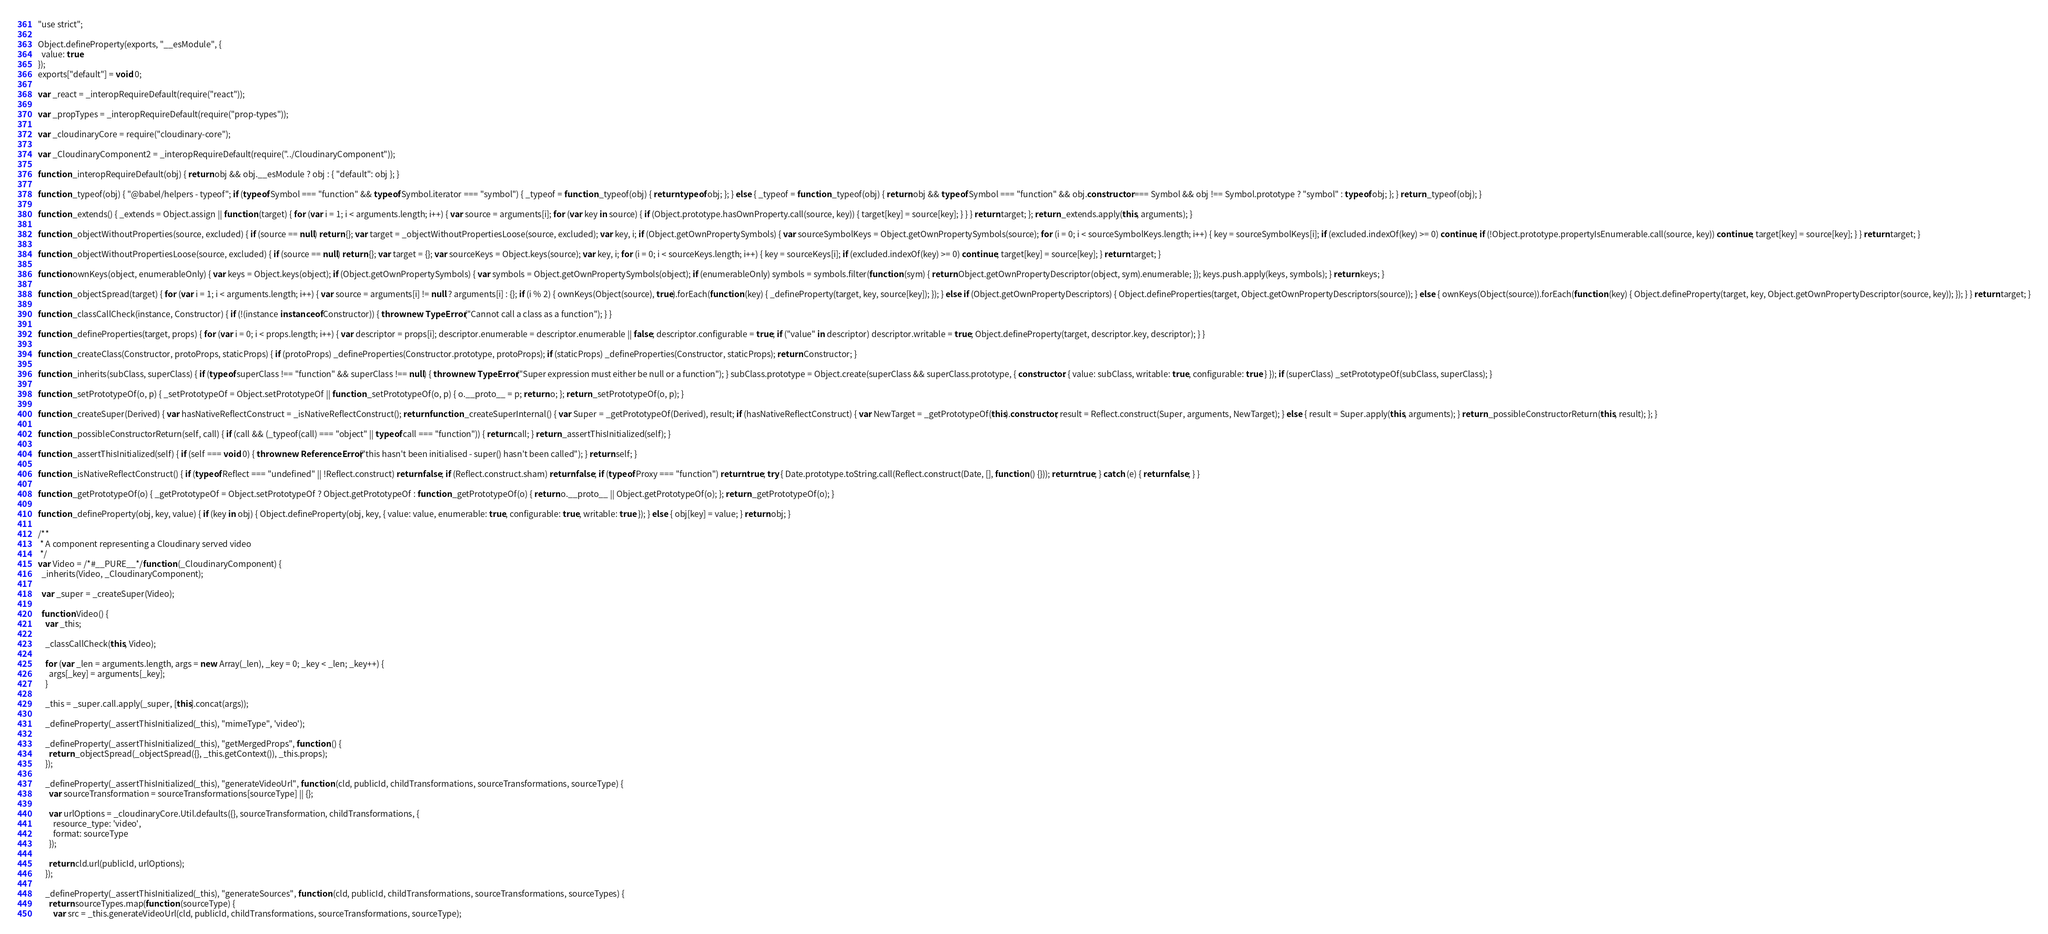Convert code to text. <code><loc_0><loc_0><loc_500><loc_500><_JavaScript_>"use strict";

Object.defineProperty(exports, "__esModule", {
  value: true
});
exports["default"] = void 0;

var _react = _interopRequireDefault(require("react"));

var _propTypes = _interopRequireDefault(require("prop-types"));

var _cloudinaryCore = require("cloudinary-core");

var _CloudinaryComponent2 = _interopRequireDefault(require("../CloudinaryComponent"));

function _interopRequireDefault(obj) { return obj && obj.__esModule ? obj : { "default": obj }; }

function _typeof(obj) { "@babel/helpers - typeof"; if (typeof Symbol === "function" && typeof Symbol.iterator === "symbol") { _typeof = function _typeof(obj) { return typeof obj; }; } else { _typeof = function _typeof(obj) { return obj && typeof Symbol === "function" && obj.constructor === Symbol && obj !== Symbol.prototype ? "symbol" : typeof obj; }; } return _typeof(obj); }

function _extends() { _extends = Object.assign || function (target) { for (var i = 1; i < arguments.length; i++) { var source = arguments[i]; for (var key in source) { if (Object.prototype.hasOwnProperty.call(source, key)) { target[key] = source[key]; } } } return target; }; return _extends.apply(this, arguments); }

function _objectWithoutProperties(source, excluded) { if (source == null) return {}; var target = _objectWithoutPropertiesLoose(source, excluded); var key, i; if (Object.getOwnPropertySymbols) { var sourceSymbolKeys = Object.getOwnPropertySymbols(source); for (i = 0; i < sourceSymbolKeys.length; i++) { key = sourceSymbolKeys[i]; if (excluded.indexOf(key) >= 0) continue; if (!Object.prototype.propertyIsEnumerable.call(source, key)) continue; target[key] = source[key]; } } return target; }

function _objectWithoutPropertiesLoose(source, excluded) { if (source == null) return {}; var target = {}; var sourceKeys = Object.keys(source); var key, i; for (i = 0; i < sourceKeys.length; i++) { key = sourceKeys[i]; if (excluded.indexOf(key) >= 0) continue; target[key] = source[key]; } return target; }

function ownKeys(object, enumerableOnly) { var keys = Object.keys(object); if (Object.getOwnPropertySymbols) { var symbols = Object.getOwnPropertySymbols(object); if (enumerableOnly) symbols = symbols.filter(function (sym) { return Object.getOwnPropertyDescriptor(object, sym).enumerable; }); keys.push.apply(keys, symbols); } return keys; }

function _objectSpread(target) { for (var i = 1; i < arguments.length; i++) { var source = arguments[i] != null ? arguments[i] : {}; if (i % 2) { ownKeys(Object(source), true).forEach(function (key) { _defineProperty(target, key, source[key]); }); } else if (Object.getOwnPropertyDescriptors) { Object.defineProperties(target, Object.getOwnPropertyDescriptors(source)); } else { ownKeys(Object(source)).forEach(function (key) { Object.defineProperty(target, key, Object.getOwnPropertyDescriptor(source, key)); }); } } return target; }

function _classCallCheck(instance, Constructor) { if (!(instance instanceof Constructor)) { throw new TypeError("Cannot call a class as a function"); } }

function _defineProperties(target, props) { for (var i = 0; i < props.length; i++) { var descriptor = props[i]; descriptor.enumerable = descriptor.enumerable || false; descriptor.configurable = true; if ("value" in descriptor) descriptor.writable = true; Object.defineProperty(target, descriptor.key, descriptor); } }

function _createClass(Constructor, protoProps, staticProps) { if (protoProps) _defineProperties(Constructor.prototype, protoProps); if (staticProps) _defineProperties(Constructor, staticProps); return Constructor; }

function _inherits(subClass, superClass) { if (typeof superClass !== "function" && superClass !== null) { throw new TypeError("Super expression must either be null or a function"); } subClass.prototype = Object.create(superClass && superClass.prototype, { constructor: { value: subClass, writable: true, configurable: true } }); if (superClass) _setPrototypeOf(subClass, superClass); }

function _setPrototypeOf(o, p) { _setPrototypeOf = Object.setPrototypeOf || function _setPrototypeOf(o, p) { o.__proto__ = p; return o; }; return _setPrototypeOf(o, p); }

function _createSuper(Derived) { var hasNativeReflectConstruct = _isNativeReflectConstruct(); return function _createSuperInternal() { var Super = _getPrototypeOf(Derived), result; if (hasNativeReflectConstruct) { var NewTarget = _getPrototypeOf(this).constructor; result = Reflect.construct(Super, arguments, NewTarget); } else { result = Super.apply(this, arguments); } return _possibleConstructorReturn(this, result); }; }

function _possibleConstructorReturn(self, call) { if (call && (_typeof(call) === "object" || typeof call === "function")) { return call; } return _assertThisInitialized(self); }

function _assertThisInitialized(self) { if (self === void 0) { throw new ReferenceError("this hasn't been initialised - super() hasn't been called"); } return self; }

function _isNativeReflectConstruct() { if (typeof Reflect === "undefined" || !Reflect.construct) return false; if (Reflect.construct.sham) return false; if (typeof Proxy === "function") return true; try { Date.prototype.toString.call(Reflect.construct(Date, [], function () {})); return true; } catch (e) { return false; } }

function _getPrototypeOf(o) { _getPrototypeOf = Object.setPrototypeOf ? Object.getPrototypeOf : function _getPrototypeOf(o) { return o.__proto__ || Object.getPrototypeOf(o); }; return _getPrototypeOf(o); }

function _defineProperty(obj, key, value) { if (key in obj) { Object.defineProperty(obj, key, { value: value, enumerable: true, configurable: true, writable: true }); } else { obj[key] = value; } return obj; }

/**
 * A component representing a Cloudinary served video
 */
var Video = /*#__PURE__*/function (_CloudinaryComponent) {
  _inherits(Video, _CloudinaryComponent);

  var _super = _createSuper(Video);

  function Video() {
    var _this;

    _classCallCheck(this, Video);

    for (var _len = arguments.length, args = new Array(_len), _key = 0; _key < _len; _key++) {
      args[_key] = arguments[_key];
    }

    _this = _super.call.apply(_super, [this].concat(args));

    _defineProperty(_assertThisInitialized(_this), "mimeType", 'video');

    _defineProperty(_assertThisInitialized(_this), "getMergedProps", function () {
      return _objectSpread(_objectSpread({}, _this.getContext()), _this.props);
    });

    _defineProperty(_assertThisInitialized(_this), "generateVideoUrl", function (cld, publicId, childTransformations, sourceTransformations, sourceType) {
      var sourceTransformation = sourceTransformations[sourceType] || {};

      var urlOptions = _cloudinaryCore.Util.defaults({}, sourceTransformation, childTransformations, {
        resource_type: 'video',
        format: sourceType
      });

      return cld.url(publicId, urlOptions);
    });

    _defineProperty(_assertThisInitialized(_this), "generateSources", function (cld, publicId, childTransformations, sourceTransformations, sourceTypes) {
      return sourceTypes.map(function (sourceType) {
        var src = _this.generateVideoUrl(cld, publicId, childTransformations, sourceTransformations, sourceType);
</code> 